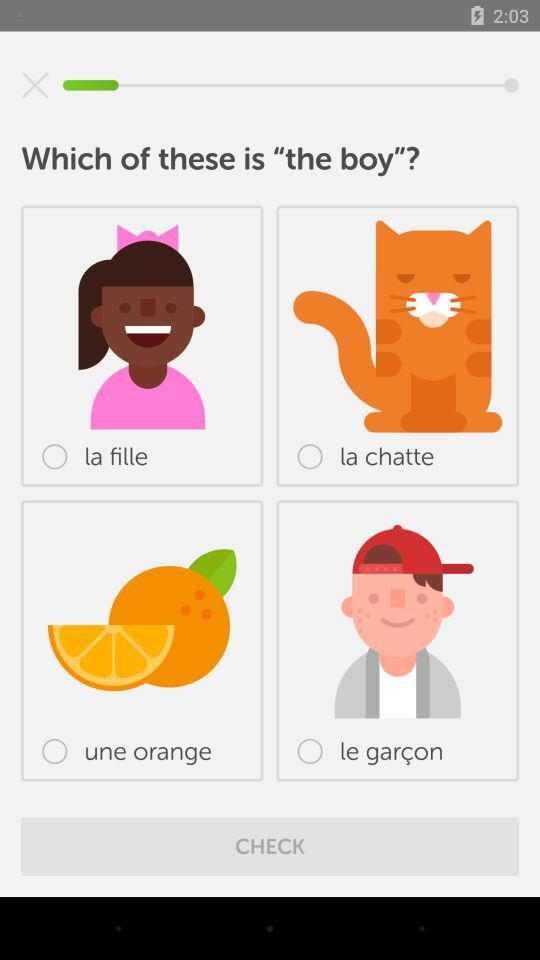How many items are not a boy?
Answer the question using a single word or phrase. 3 